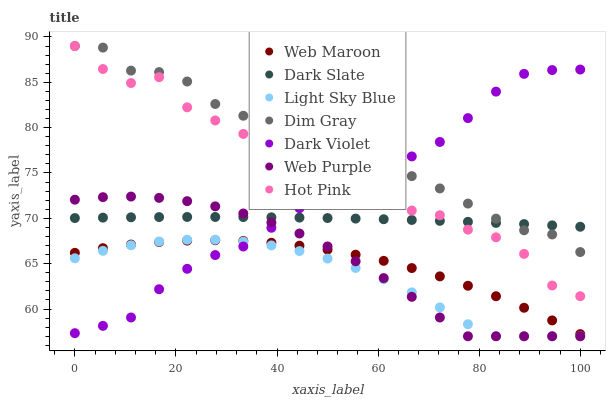Does Light Sky Blue have the minimum area under the curve?
Answer yes or no. Yes. Does Dim Gray have the maximum area under the curve?
Answer yes or no. Yes. Does Hot Pink have the minimum area under the curve?
Answer yes or no. No. Does Hot Pink have the maximum area under the curve?
Answer yes or no. No. Is Dark Slate the smoothest?
Answer yes or no. Yes. Is Dim Gray the roughest?
Answer yes or no. Yes. Is Hot Pink the smoothest?
Answer yes or no. No. Is Hot Pink the roughest?
Answer yes or no. No. Does Web Purple have the lowest value?
Answer yes or no. Yes. Does Hot Pink have the lowest value?
Answer yes or no. No. Does Hot Pink have the highest value?
Answer yes or no. Yes. Does Web Maroon have the highest value?
Answer yes or no. No. Is Web Maroon less than Dark Slate?
Answer yes or no. Yes. Is Hot Pink greater than Web Purple?
Answer yes or no. Yes. Does Web Maroon intersect Light Sky Blue?
Answer yes or no. Yes. Is Web Maroon less than Light Sky Blue?
Answer yes or no. No. Is Web Maroon greater than Light Sky Blue?
Answer yes or no. No. Does Web Maroon intersect Dark Slate?
Answer yes or no. No. 